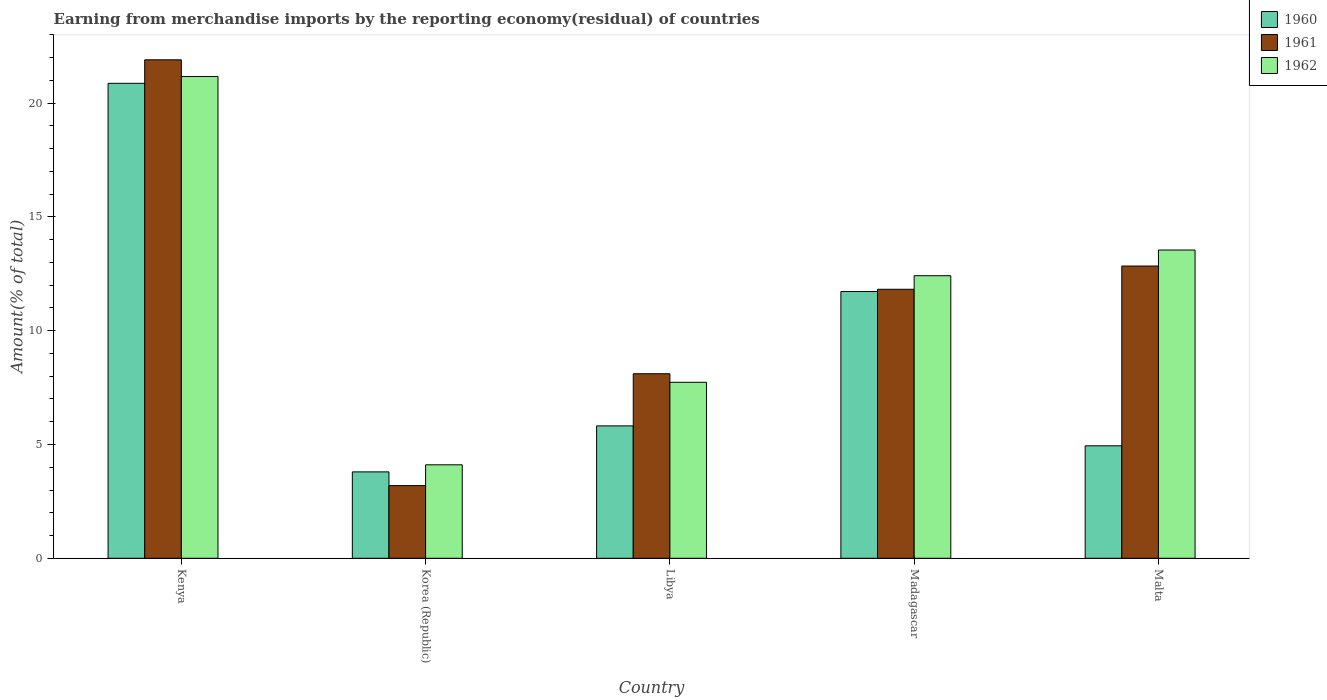How many different coloured bars are there?
Keep it short and to the point. 3. How many bars are there on the 2nd tick from the left?
Keep it short and to the point. 3. How many bars are there on the 1st tick from the right?
Make the answer very short. 3. What is the label of the 1st group of bars from the left?
Give a very brief answer. Kenya. In how many cases, is the number of bars for a given country not equal to the number of legend labels?
Provide a short and direct response. 0. What is the percentage of amount earned from merchandise imports in 1962 in Libya?
Make the answer very short. 7.73. Across all countries, what is the maximum percentage of amount earned from merchandise imports in 1961?
Offer a very short reply. 21.91. Across all countries, what is the minimum percentage of amount earned from merchandise imports in 1961?
Offer a terse response. 3.19. In which country was the percentage of amount earned from merchandise imports in 1961 maximum?
Your answer should be very brief. Kenya. What is the total percentage of amount earned from merchandise imports in 1961 in the graph?
Give a very brief answer. 57.88. What is the difference between the percentage of amount earned from merchandise imports in 1960 in Libya and that in Malta?
Keep it short and to the point. 0.88. What is the difference between the percentage of amount earned from merchandise imports in 1960 in Malta and the percentage of amount earned from merchandise imports in 1961 in Korea (Republic)?
Ensure brevity in your answer.  1.75. What is the average percentage of amount earned from merchandise imports in 1961 per country?
Ensure brevity in your answer.  11.58. What is the difference between the percentage of amount earned from merchandise imports of/in 1960 and percentage of amount earned from merchandise imports of/in 1961 in Kenya?
Keep it short and to the point. -1.03. In how many countries, is the percentage of amount earned from merchandise imports in 1961 greater than 11 %?
Offer a very short reply. 3. What is the ratio of the percentage of amount earned from merchandise imports in 1962 in Korea (Republic) to that in Madagascar?
Provide a succinct answer. 0.33. What is the difference between the highest and the second highest percentage of amount earned from merchandise imports in 1961?
Keep it short and to the point. -1.02. What is the difference between the highest and the lowest percentage of amount earned from merchandise imports in 1961?
Your response must be concise. 18.71. In how many countries, is the percentage of amount earned from merchandise imports in 1960 greater than the average percentage of amount earned from merchandise imports in 1960 taken over all countries?
Offer a very short reply. 2. Is the sum of the percentage of amount earned from merchandise imports in 1961 in Kenya and Libya greater than the maximum percentage of amount earned from merchandise imports in 1960 across all countries?
Make the answer very short. Yes. Are all the bars in the graph horizontal?
Your response must be concise. No. Does the graph contain grids?
Give a very brief answer. No. Where does the legend appear in the graph?
Ensure brevity in your answer.  Top right. What is the title of the graph?
Ensure brevity in your answer.  Earning from merchandise imports by the reporting economy(residual) of countries. What is the label or title of the Y-axis?
Give a very brief answer. Amount(% of total). What is the Amount(% of total) in 1960 in Kenya?
Provide a succinct answer. 20.87. What is the Amount(% of total) in 1961 in Kenya?
Ensure brevity in your answer.  21.91. What is the Amount(% of total) of 1962 in Kenya?
Your answer should be compact. 21.17. What is the Amount(% of total) of 1960 in Korea (Republic)?
Offer a very short reply. 3.8. What is the Amount(% of total) of 1961 in Korea (Republic)?
Offer a very short reply. 3.19. What is the Amount(% of total) of 1962 in Korea (Republic)?
Make the answer very short. 4.11. What is the Amount(% of total) of 1960 in Libya?
Provide a short and direct response. 5.82. What is the Amount(% of total) of 1961 in Libya?
Your answer should be very brief. 8.11. What is the Amount(% of total) in 1962 in Libya?
Offer a very short reply. 7.73. What is the Amount(% of total) of 1960 in Madagascar?
Give a very brief answer. 11.72. What is the Amount(% of total) of 1961 in Madagascar?
Ensure brevity in your answer.  11.82. What is the Amount(% of total) in 1962 in Madagascar?
Your response must be concise. 12.42. What is the Amount(% of total) of 1960 in Malta?
Provide a short and direct response. 4.94. What is the Amount(% of total) in 1961 in Malta?
Provide a short and direct response. 12.84. What is the Amount(% of total) in 1962 in Malta?
Offer a terse response. 13.55. Across all countries, what is the maximum Amount(% of total) of 1960?
Give a very brief answer. 20.87. Across all countries, what is the maximum Amount(% of total) of 1961?
Your answer should be very brief. 21.91. Across all countries, what is the maximum Amount(% of total) of 1962?
Your answer should be compact. 21.17. Across all countries, what is the minimum Amount(% of total) in 1960?
Keep it short and to the point. 3.8. Across all countries, what is the minimum Amount(% of total) of 1961?
Provide a succinct answer. 3.19. Across all countries, what is the minimum Amount(% of total) of 1962?
Your answer should be compact. 4.11. What is the total Amount(% of total) in 1960 in the graph?
Offer a very short reply. 47.15. What is the total Amount(% of total) in 1961 in the graph?
Offer a terse response. 57.88. What is the total Amount(% of total) of 1962 in the graph?
Provide a succinct answer. 58.98. What is the difference between the Amount(% of total) of 1960 in Kenya and that in Korea (Republic)?
Provide a short and direct response. 17.08. What is the difference between the Amount(% of total) of 1961 in Kenya and that in Korea (Republic)?
Your response must be concise. 18.71. What is the difference between the Amount(% of total) in 1962 in Kenya and that in Korea (Republic)?
Your answer should be very brief. 17.06. What is the difference between the Amount(% of total) in 1960 in Kenya and that in Libya?
Ensure brevity in your answer.  15.06. What is the difference between the Amount(% of total) of 1961 in Kenya and that in Libya?
Offer a terse response. 13.8. What is the difference between the Amount(% of total) of 1962 in Kenya and that in Libya?
Your answer should be very brief. 13.44. What is the difference between the Amount(% of total) in 1960 in Kenya and that in Madagascar?
Give a very brief answer. 9.15. What is the difference between the Amount(% of total) of 1961 in Kenya and that in Madagascar?
Ensure brevity in your answer.  10.09. What is the difference between the Amount(% of total) of 1962 in Kenya and that in Madagascar?
Provide a short and direct response. 8.75. What is the difference between the Amount(% of total) of 1960 in Kenya and that in Malta?
Offer a terse response. 15.93. What is the difference between the Amount(% of total) of 1961 in Kenya and that in Malta?
Give a very brief answer. 9.06. What is the difference between the Amount(% of total) of 1962 in Kenya and that in Malta?
Ensure brevity in your answer.  7.62. What is the difference between the Amount(% of total) in 1960 in Korea (Republic) and that in Libya?
Offer a very short reply. -2.02. What is the difference between the Amount(% of total) of 1961 in Korea (Republic) and that in Libya?
Give a very brief answer. -4.92. What is the difference between the Amount(% of total) of 1962 in Korea (Republic) and that in Libya?
Offer a very short reply. -3.63. What is the difference between the Amount(% of total) in 1960 in Korea (Republic) and that in Madagascar?
Your response must be concise. -7.93. What is the difference between the Amount(% of total) of 1961 in Korea (Republic) and that in Madagascar?
Offer a terse response. -8.63. What is the difference between the Amount(% of total) in 1962 in Korea (Republic) and that in Madagascar?
Offer a very short reply. -8.31. What is the difference between the Amount(% of total) in 1960 in Korea (Republic) and that in Malta?
Keep it short and to the point. -1.15. What is the difference between the Amount(% of total) in 1961 in Korea (Republic) and that in Malta?
Provide a short and direct response. -9.65. What is the difference between the Amount(% of total) of 1962 in Korea (Republic) and that in Malta?
Provide a succinct answer. -9.44. What is the difference between the Amount(% of total) in 1960 in Libya and that in Madagascar?
Ensure brevity in your answer.  -5.9. What is the difference between the Amount(% of total) of 1961 in Libya and that in Madagascar?
Ensure brevity in your answer.  -3.71. What is the difference between the Amount(% of total) in 1962 in Libya and that in Madagascar?
Make the answer very short. -4.68. What is the difference between the Amount(% of total) in 1960 in Libya and that in Malta?
Keep it short and to the point. 0.88. What is the difference between the Amount(% of total) in 1961 in Libya and that in Malta?
Offer a very short reply. -4.73. What is the difference between the Amount(% of total) in 1962 in Libya and that in Malta?
Your answer should be compact. -5.81. What is the difference between the Amount(% of total) in 1960 in Madagascar and that in Malta?
Keep it short and to the point. 6.78. What is the difference between the Amount(% of total) in 1961 in Madagascar and that in Malta?
Your response must be concise. -1.02. What is the difference between the Amount(% of total) of 1962 in Madagascar and that in Malta?
Make the answer very short. -1.13. What is the difference between the Amount(% of total) in 1960 in Kenya and the Amount(% of total) in 1961 in Korea (Republic)?
Your answer should be compact. 17.68. What is the difference between the Amount(% of total) of 1960 in Kenya and the Amount(% of total) of 1962 in Korea (Republic)?
Provide a succinct answer. 16.77. What is the difference between the Amount(% of total) of 1961 in Kenya and the Amount(% of total) of 1962 in Korea (Republic)?
Provide a succinct answer. 17.8. What is the difference between the Amount(% of total) of 1960 in Kenya and the Amount(% of total) of 1961 in Libya?
Make the answer very short. 12.76. What is the difference between the Amount(% of total) in 1960 in Kenya and the Amount(% of total) in 1962 in Libya?
Ensure brevity in your answer.  13.14. What is the difference between the Amount(% of total) in 1961 in Kenya and the Amount(% of total) in 1962 in Libya?
Your answer should be compact. 14.17. What is the difference between the Amount(% of total) of 1960 in Kenya and the Amount(% of total) of 1961 in Madagascar?
Your answer should be very brief. 9.05. What is the difference between the Amount(% of total) of 1960 in Kenya and the Amount(% of total) of 1962 in Madagascar?
Offer a terse response. 8.46. What is the difference between the Amount(% of total) in 1961 in Kenya and the Amount(% of total) in 1962 in Madagascar?
Keep it short and to the point. 9.49. What is the difference between the Amount(% of total) in 1960 in Kenya and the Amount(% of total) in 1961 in Malta?
Give a very brief answer. 8.03. What is the difference between the Amount(% of total) in 1960 in Kenya and the Amount(% of total) in 1962 in Malta?
Make the answer very short. 7.33. What is the difference between the Amount(% of total) of 1961 in Kenya and the Amount(% of total) of 1962 in Malta?
Ensure brevity in your answer.  8.36. What is the difference between the Amount(% of total) of 1960 in Korea (Republic) and the Amount(% of total) of 1961 in Libya?
Ensure brevity in your answer.  -4.31. What is the difference between the Amount(% of total) of 1960 in Korea (Republic) and the Amount(% of total) of 1962 in Libya?
Offer a terse response. -3.94. What is the difference between the Amount(% of total) of 1961 in Korea (Republic) and the Amount(% of total) of 1962 in Libya?
Give a very brief answer. -4.54. What is the difference between the Amount(% of total) in 1960 in Korea (Republic) and the Amount(% of total) in 1961 in Madagascar?
Your answer should be very brief. -8.03. What is the difference between the Amount(% of total) of 1960 in Korea (Republic) and the Amount(% of total) of 1962 in Madagascar?
Give a very brief answer. -8.62. What is the difference between the Amount(% of total) in 1961 in Korea (Republic) and the Amount(% of total) in 1962 in Madagascar?
Give a very brief answer. -9.22. What is the difference between the Amount(% of total) of 1960 in Korea (Republic) and the Amount(% of total) of 1961 in Malta?
Provide a short and direct response. -9.05. What is the difference between the Amount(% of total) of 1960 in Korea (Republic) and the Amount(% of total) of 1962 in Malta?
Provide a short and direct response. -9.75. What is the difference between the Amount(% of total) in 1961 in Korea (Republic) and the Amount(% of total) in 1962 in Malta?
Your answer should be very brief. -10.35. What is the difference between the Amount(% of total) of 1960 in Libya and the Amount(% of total) of 1961 in Madagascar?
Provide a succinct answer. -6. What is the difference between the Amount(% of total) of 1960 in Libya and the Amount(% of total) of 1962 in Madagascar?
Your answer should be very brief. -6.6. What is the difference between the Amount(% of total) of 1961 in Libya and the Amount(% of total) of 1962 in Madagascar?
Provide a short and direct response. -4.31. What is the difference between the Amount(% of total) in 1960 in Libya and the Amount(% of total) in 1961 in Malta?
Give a very brief answer. -7.03. What is the difference between the Amount(% of total) of 1960 in Libya and the Amount(% of total) of 1962 in Malta?
Ensure brevity in your answer.  -7.73. What is the difference between the Amount(% of total) in 1961 in Libya and the Amount(% of total) in 1962 in Malta?
Provide a short and direct response. -5.44. What is the difference between the Amount(% of total) in 1960 in Madagascar and the Amount(% of total) in 1961 in Malta?
Ensure brevity in your answer.  -1.12. What is the difference between the Amount(% of total) in 1960 in Madagascar and the Amount(% of total) in 1962 in Malta?
Ensure brevity in your answer.  -1.82. What is the difference between the Amount(% of total) in 1961 in Madagascar and the Amount(% of total) in 1962 in Malta?
Your answer should be very brief. -1.73. What is the average Amount(% of total) in 1960 per country?
Ensure brevity in your answer.  9.43. What is the average Amount(% of total) in 1961 per country?
Make the answer very short. 11.58. What is the average Amount(% of total) of 1962 per country?
Provide a succinct answer. 11.8. What is the difference between the Amount(% of total) in 1960 and Amount(% of total) in 1961 in Kenya?
Offer a terse response. -1.03. What is the difference between the Amount(% of total) in 1960 and Amount(% of total) in 1962 in Kenya?
Keep it short and to the point. -0.3. What is the difference between the Amount(% of total) in 1961 and Amount(% of total) in 1962 in Kenya?
Offer a very short reply. 0.74. What is the difference between the Amount(% of total) in 1960 and Amount(% of total) in 1961 in Korea (Republic)?
Your response must be concise. 0.6. What is the difference between the Amount(% of total) in 1960 and Amount(% of total) in 1962 in Korea (Republic)?
Provide a short and direct response. -0.31. What is the difference between the Amount(% of total) of 1961 and Amount(% of total) of 1962 in Korea (Republic)?
Your response must be concise. -0.91. What is the difference between the Amount(% of total) in 1960 and Amount(% of total) in 1961 in Libya?
Make the answer very short. -2.29. What is the difference between the Amount(% of total) in 1960 and Amount(% of total) in 1962 in Libya?
Make the answer very short. -1.92. What is the difference between the Amount(% of total) in 1961 and Amount(% of total) in 1962 in Libya?
Offer a terse response. 0.38. What is the difference between the Amount(% of total) in 1960 and Amount(% of total) in 1961 in Madagascar?
Offer a very short reply. -0.1. What is the difference between the Amount(% of total) in 1960 and Amount(% of total) in 1962 in Madagascar?
Offer a terse response. -0.7. What is the difference between the Amount(% of total) in 1961 and Amount(% of total) in 1962 in Madagascar?
Ensure brevity in your answer.  -0.6. What is the difference between the Amount(% of total) of 1960 and Amount(% of total) of 1961 in Malta?
Provide a short and direct response. -7.9. What is the difference between the Amount(% of total) of 1960 and Amount(% of total) of 1962 in Malta?
Provide a succinct answer. -8.6. What is the difference between the Amount(% of total) in 1961 and Amount(% of total) in 1962 in Malta?
Ensure brevity in your answer.  -0.7. What is the ratio of the Amount(% of total) in 1960 in Kenya to that in Korea (Republic)?
Give a very brief answer. 5.5. What is the ratio of the Amount(% of total) in 1961 in Kenya to that in Korea (Republic)?
Your response must be concise. 6.86. What is the ratio of the Amount(% of total) of 1962 in Kenya to that in Korea (Republic)?
Keep it short and to the point. 5.15. What is the ratio of the Amount(% of total) in 1960 in Kenya to that in Libya?
Ensure brevity in your answer.  3.59. What is the ratio of the Amount(% of total) of 1961 in Kenya to that in Libya?
Your answer should be compact. 2.7. What is the ratio of the Amount(% of total) in 1962 in Kenya to that in Libya?
Your answer should be very brief. 2.74. What is the ratio of the Amount(% of total) of 1960 in Kenya to that in Madagascar?
Make the answer very short. 1.78. What is the ratio of the Amount(% of total) in 1961 in Kenya to that in Madagascar?
Your response must be concise. 1.85. What is the ratio of the Amount(% of total) of 1962 in Kenya to that in Madagascar?
Your answer should be very brief. 1.7. What is the ratio of the Amount(% of total) of 1960 in Kenya to that in Malta?
Your answer should be very brief. 4.22. What is the ratio of the Amount(% of total) in 1961 in Kenya to that in Malta?
Offer a terse response. 1.71. What is the ratio of the Amount(% of total) of 1962 in Kenya to that in Malta?
Provide a succinct answer. 1.56. What is the ratio of the Amount(% of total) of 1960 in Korea (Republic) to that in Libya?
Offer a very short reply. 0.65. What is the ratio of the Amount(% of total) of 1961 in Korea (Republic) to that in Libya?
Offer a terse response. 0.39. What is the ratio of the Amount(% of total) of 1962 in Korea (Republic) to that in Libya?
Offer a terse response. 0.53. What is the ratio of the Amount(% of total) of 1960 in Korea (Republic) to that in Madagascar?
Provide a succinct answer. 0.32. What is the ratio of the Amount(% of total) of 1961 in Korea (Republic) to that in Madagascar?
Offer a terse response. 0.27. What is the ratio of the Amount(% of total) of 1962 in Korea (Republic) to that in Madagascar?
Your answer should be compact. 0.33. What is the ratio of the Amount(% of total) of 1960 in Korea (Republic) to that in Malta?
Your answer should be compact. 0.77. What is the ratio of the Amount(% of total) in 1961 in Korea (Republic) to that in Malta?
Make the answer very short. 0.25. What is the ratio of the Amount(% of total) in 1962 in Korea (Republic) to that in Malta?
Your response must be concise. 0.3. What is the ratio of the Amount(% of total) of 1960 in Libya to that in Madagascar?
Keep it short and to the point. 0.5. What is the ratio of the Amount(% of total) of 1961 in Libya to that in Madagascar?
Ensure brevity in your answer.  0.69. What is the ratio of the Amount(% of total) of 1962 in Libya to that in Madagascar?
Keep it short and to the point. 0.62. What is the ratio of the Amount(% of total) in 1960 in Libya to that in Malta?
Offer a very short reply. 1.18. What is the ratio of the Amount(% of total) in 1961 in Libya to that in Malta?
Ensure brevity in your answer.  0.63. What is the ratio of the Amount(% of total) in 1962 in Libya to that in Malta?
Your answer should be compact. 0.57. What is the ratio of the Amount(% of total) in 1960 in Madagascar to that in Malta?
Make the answer very short. 2.37. What is the ratio of the Amount(% of total) of 1961 in Madagascar to that in Malta?
Your answer should be very brief. 0.92. What is the difference between the highest and the second highest Amount(% of total) of 1960?
Keep it short and to the point. 9.15. What is the difference between the highest and the second highest Amount(% of total) of 1961?
Keep it short and to the point. 9.06. What is the difference between the highest and the second highest Amount(% of total) in 1962?
Your answer should be compact. 7.62. What is the difference between the highest and the lowest Amount(% of total) of 1960?
Provide a short and direct response. 17.08. What is the difference between the highest and the lowest Amount(% of total) in 1961?
Offer a terse response. 18.71. What is the difference between the highest and the lowest Amount(% of total) in 1962?
Provide a succinct answer. 17.06. 